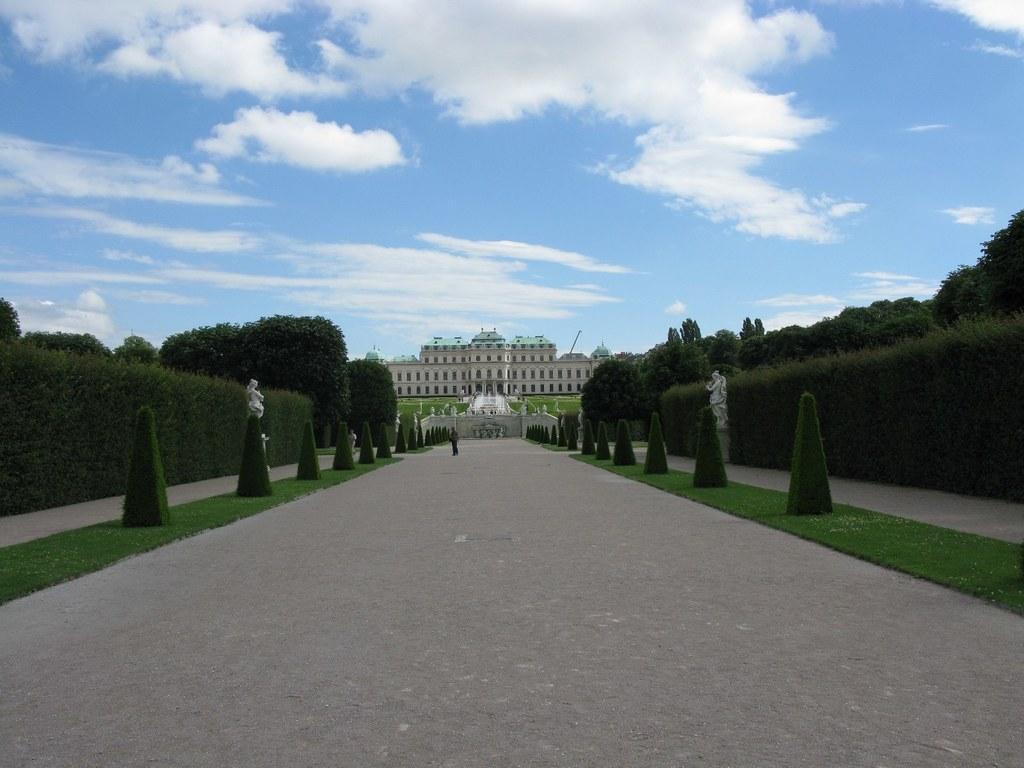How would you summarize this image in a sentence or two? There is one person standing on the road as we can see at the bottom of this image. There are trees on the left side of this image and right side of this image as well. There is a building in the middle of this image. We can see a sky at the top of this image. 